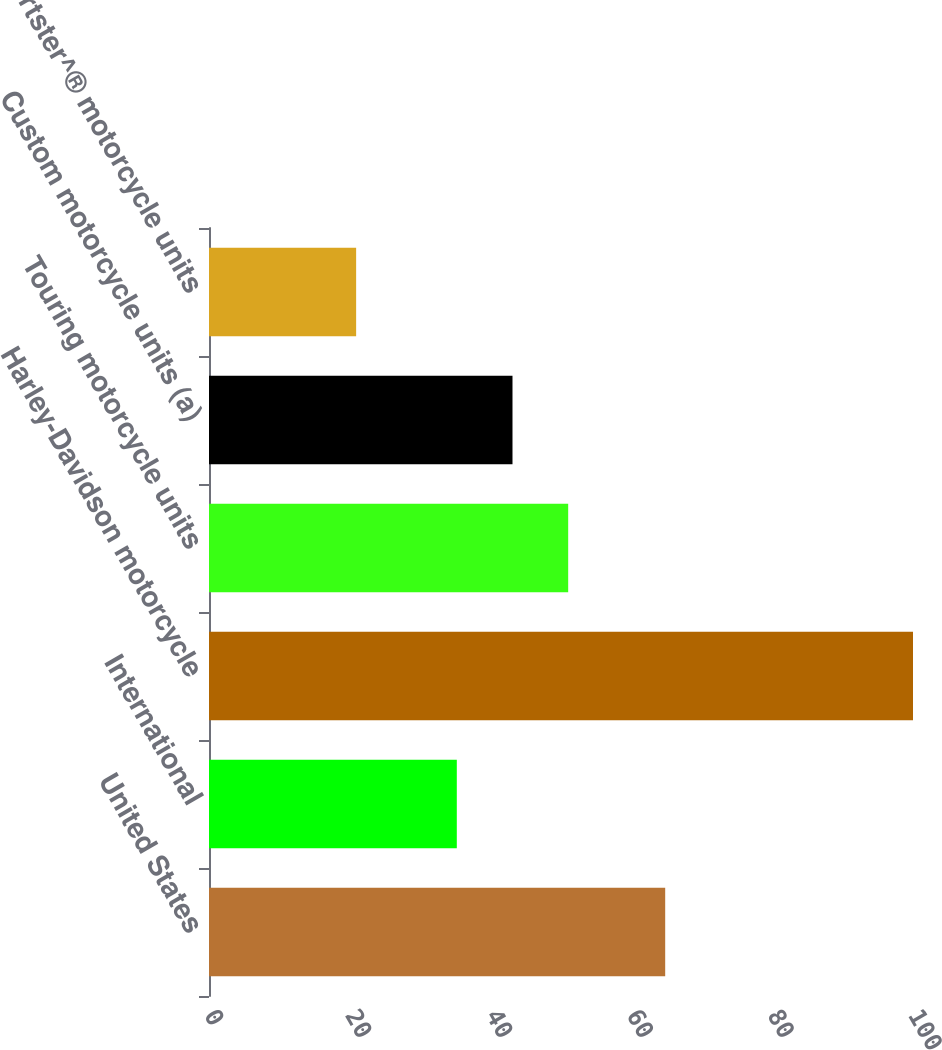Convert chart to OTSL. <chart><loc_0><loc_0><loc_500><loc_500><bar_chart><fcel>United States<fcel>International<fcel>Harley-Davidson motorcycle<fcel>Touring motorcycle units<fcel>Custom motorcycle units (a)<fcel>Sportster^® motorcycle units<nl><fcel>64.8<fcel>35.2<fcel>100<fcel>51.02<fcel>43.11<fcel>20.9<nl></chart> 